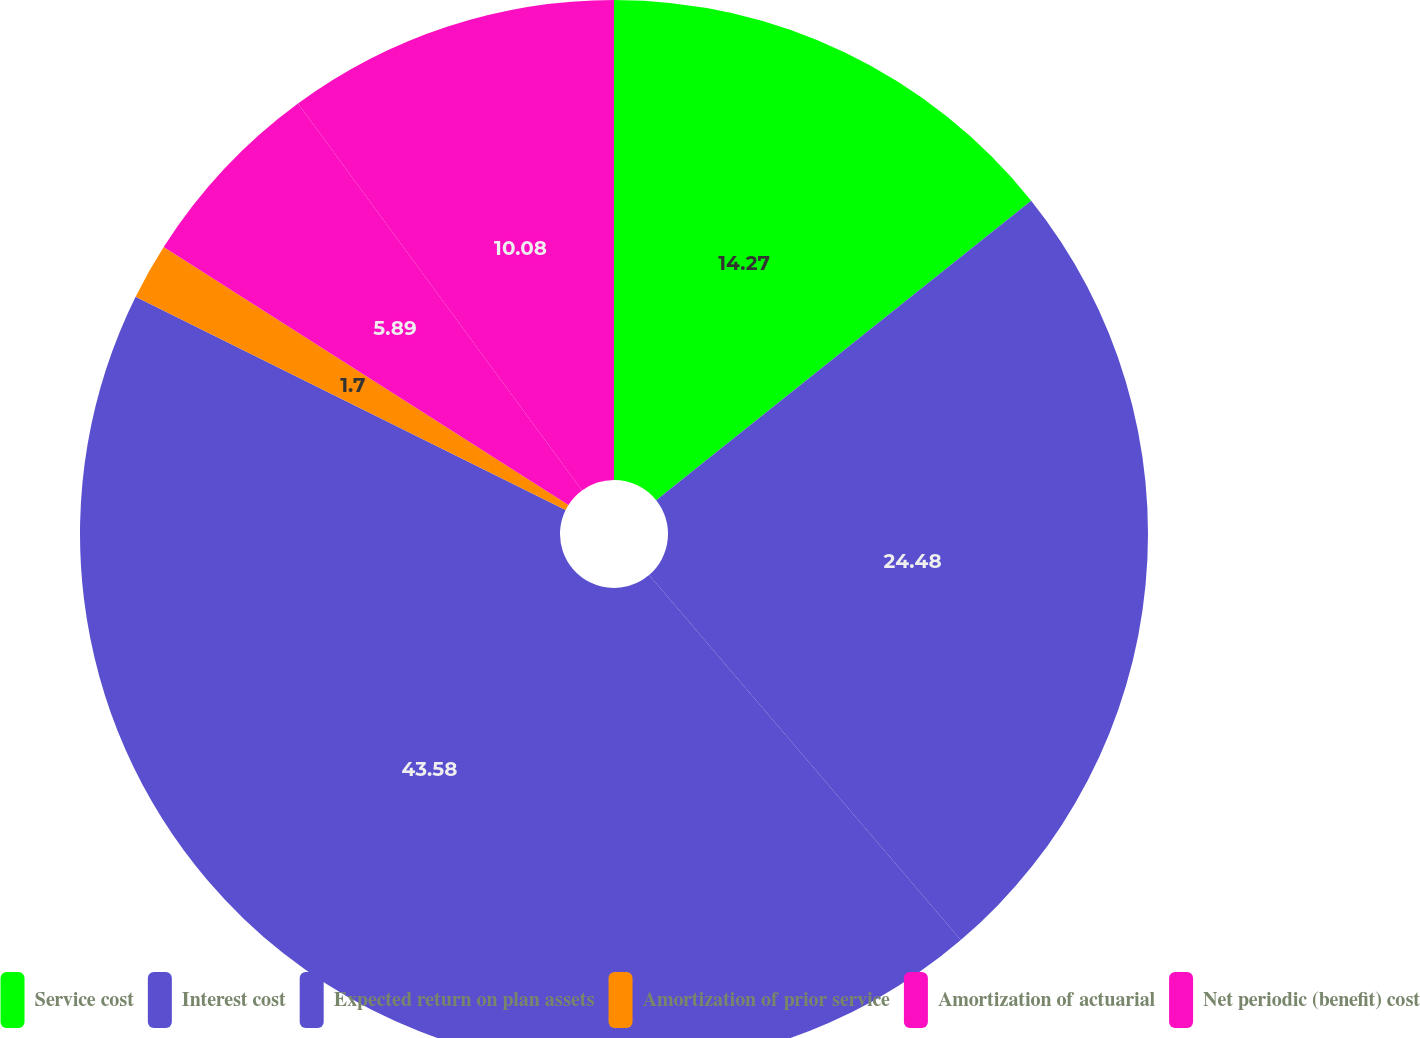Convert chart. <chart><loc_0><loc_0><loc_500><loc_500><pie_chart><fcel>Service cost<fcel>Interest cost<fcel>Expected return on plan assets<fcel>Amortization of prior service<fcel>Amortization of actuarial<fcel>Net periodic (benefit) cost<nl><fcel>14.27%<fcel>24.48%<fcel>43.58%<fcel>1.7%<fcel>5.89%<fcel>10.08%<nl></chart> 